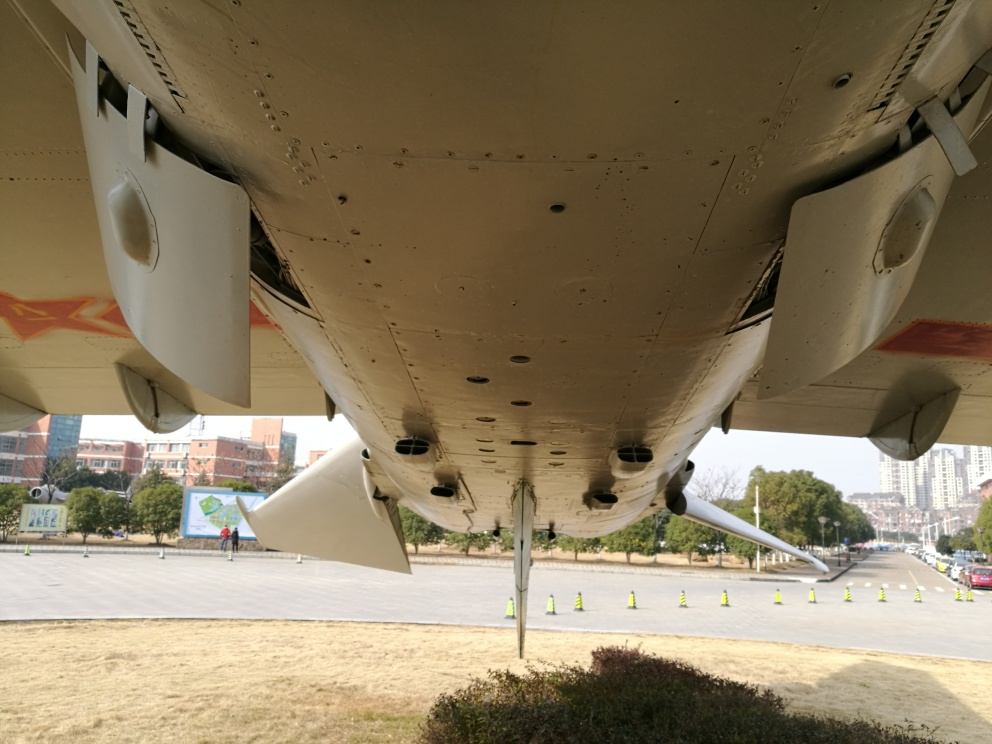Can you guess why this aircraft might be on display? Given the context of the image, it is possible that this aircraft is on display for educational or historical purposes. It might be a retired model set up for public viewing to showcase aviation history or design, or as an interactive exhibit for enthusiasts and students to learn more about airplanes and the mechanics of flight. 